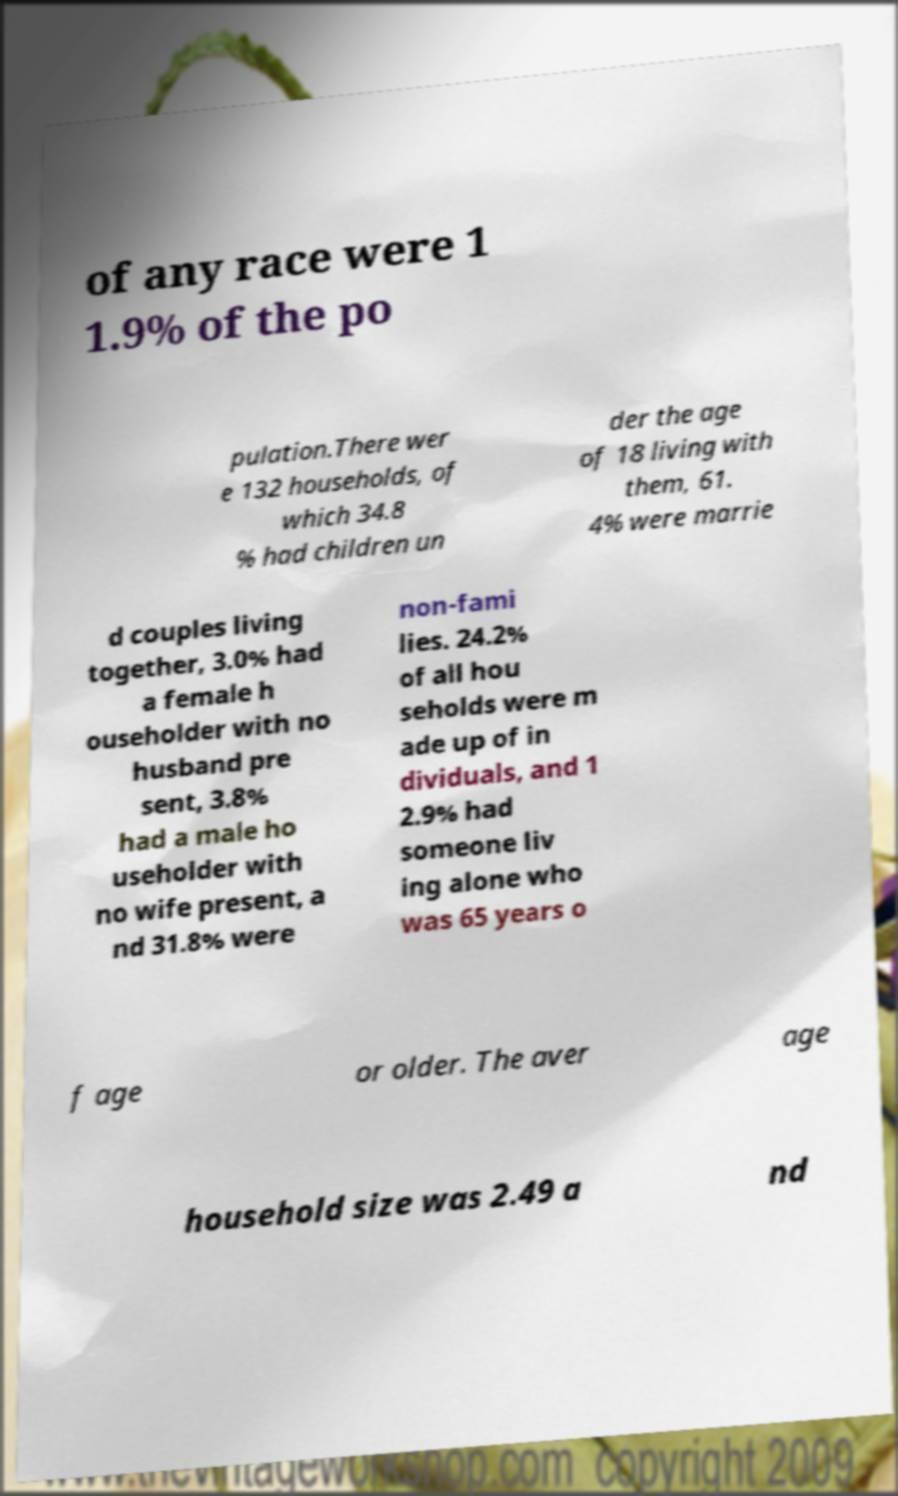What messages or text are displayed in this image? I need them in a readable, typed format. of any race were 1 1.9% of the po pulation.There wer e 132 households, of which 34.8 % had children un der the age of 18 living with them, 61. 4% were marrie d couples living together, 3.0% had a female h ouseholder with no husband pre sent, 3.8% had a male ho useholder with no wife present, a nd 31.8% were non-fami lies. 24.2% of all hou seholds were m ade up of in dividuals, and 1 2.9% had someone liv ing alone who was 65 years o f age or older. The aver age household size was 2.49 a nd 